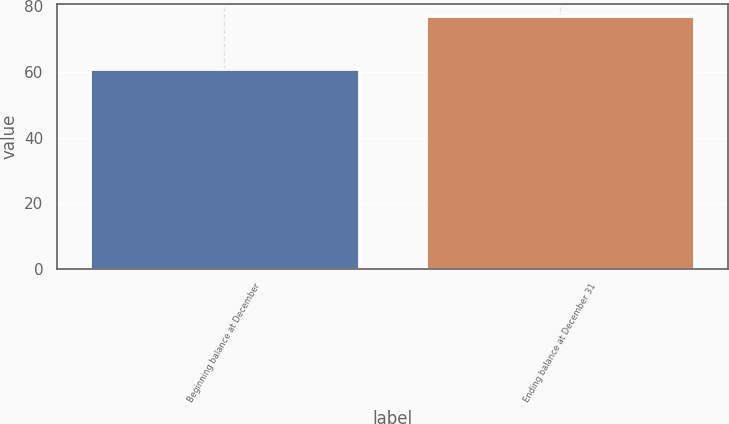Convert chart. <chart><loc_0><loc_0><loc_500><loc_500><bar_chart><fcel>Beginning balance at December<fcel>Ending balance at December 31<nl><fcel>61<fcel>77<nl></chart> 